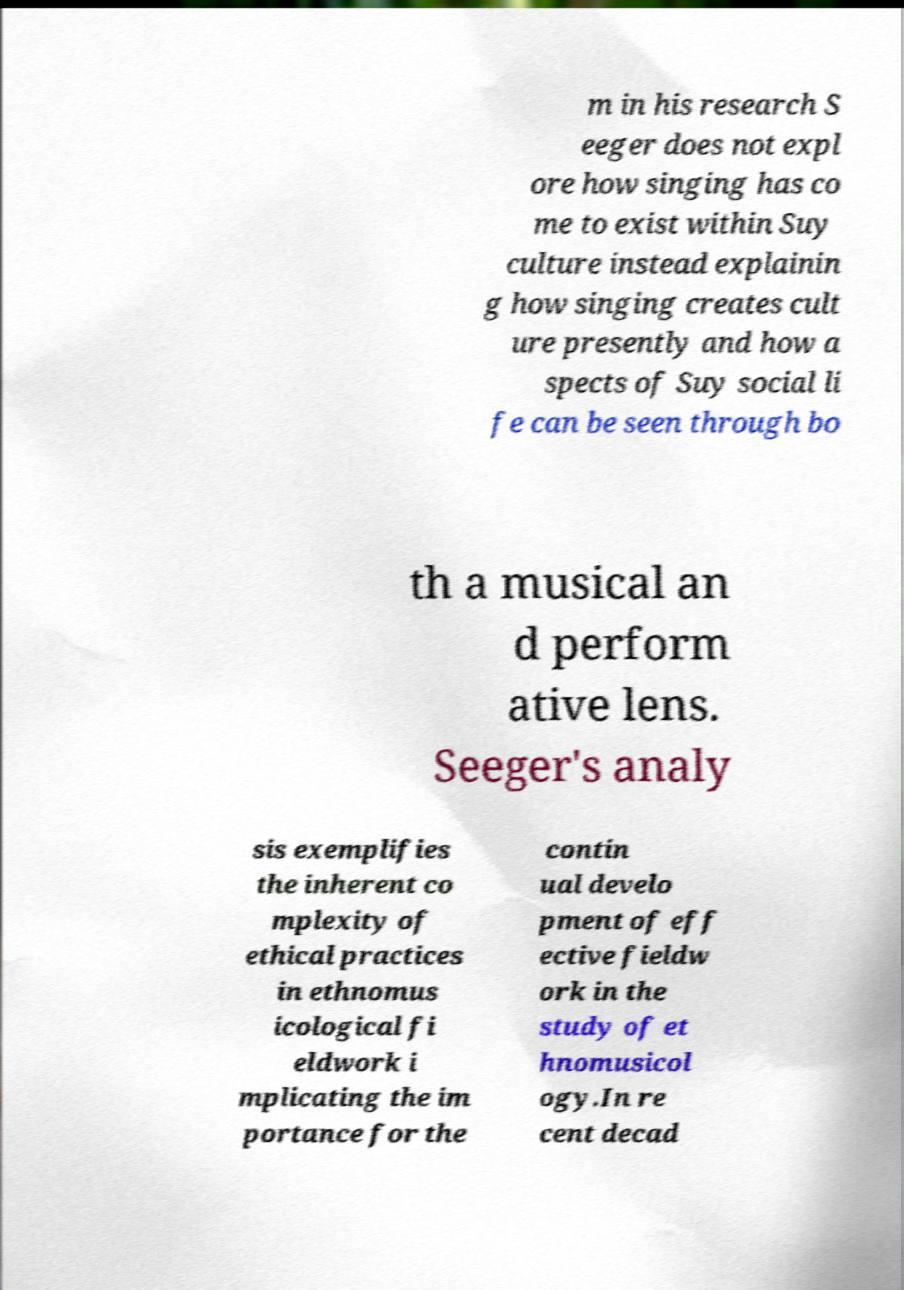There's text embedded in this image that I need extracted. Can you transcribe it verbatim? m in his research S eeger does not expl ore how singing has co me to exist within Suy culture instead explainin g how singing creates cult ure presently and how a spects of Suy social li fe can be seen through bo th a musical an d perform ative lens. Seeger's analy sis exemplifies the inherent co mplexity of ethical practices in ethnomus icological fi eldwork i mplicating the im portance for the contin ual develo pment of eff ective fieldw ork in the study of et hnomusicol ogy.In re cent decad 